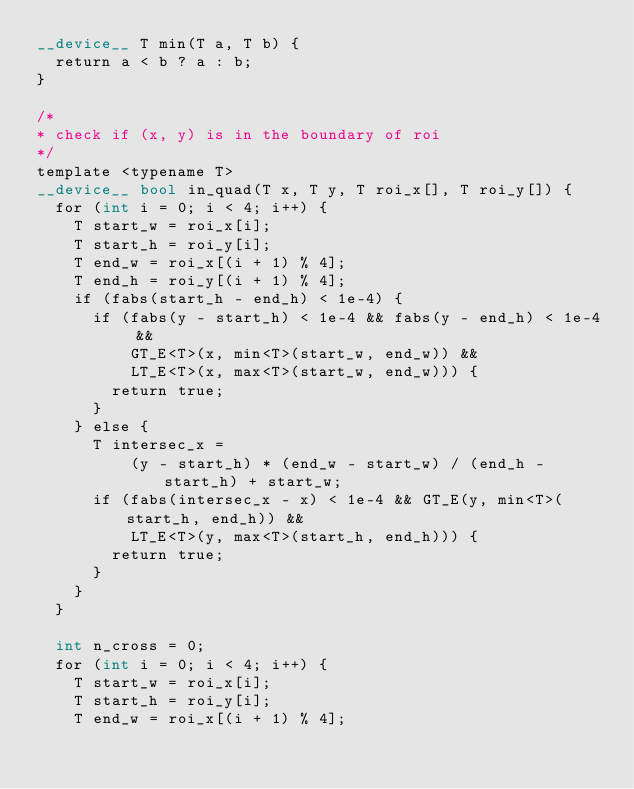<code> <loc_0><loc_0><loc_500><loc_500><_Cuda_>__device__ T min(T a, T b) {
  return a < b ? a : b;
}

/*
* check if (x, y) is in the boundary of roi
*/
template <typename T>
__device__ bool in_quad(T x, T y, T roi_x[], T roi_y[]) {
  for (int i = 0; i < 4; i++) {
    T start_w = roi_x[i];
    T start_h = roi_y[i];
    T end_w = roi_x[(i + 1) % 4];
    T end_h = roi_y[(i + 1) % 4];
    if (fabs(start_h - end_h) < 1e-4) {
      if (fabs(y - start_h) < 1e-4 && fabs(y - end_h) < 1e-4 &&
          GT_E<T>(x, min<T>(start_w, end_w)) &&
          LT_E<T>(x, max<T>(start_w, end_w))) {
        return true;
      }
    } else {
      T intersec_x =
          (y - start_h) * (end_w - start_w) / (end_h - start_h) + start_w;
      if (fabs(intersec_x - x) < 1e-4 && GT_E(y, min<T>(start_h, end_h)) &&
          LT_E<T>(y, max<T>(start_h, end_h))) {
        return true;
      }
    }
  }

  int n_cross = 0;
  for (int i = 0; i < 4; i++) {
    T start_w = roi_x[i];
    T start_h = roi_y[i];
    T end_w = roi_x[(i + 1) % 4];</code> 